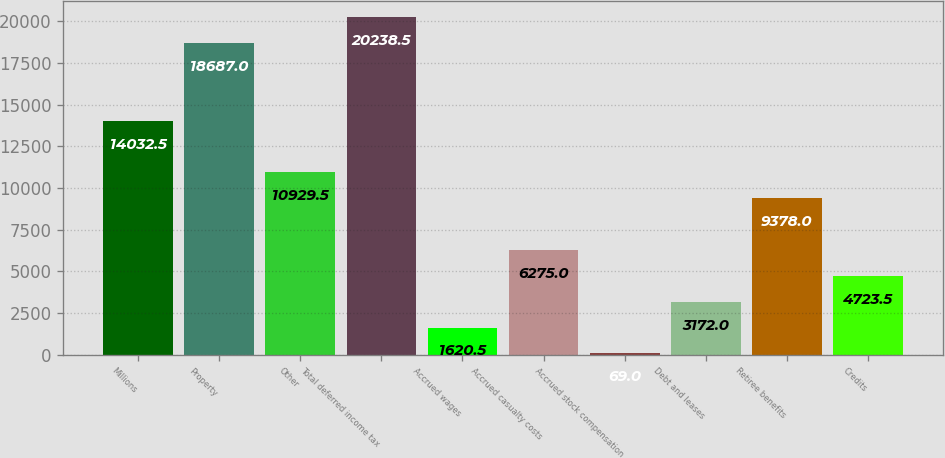Convert chart. <chart><loc_0><loc_0><loc_500><loc_500><bar_chart><fcel>Millions<fcel>Property<fcel>Other<fcel>Total deferred income tax<fcel>Accrued wages<fcel>Accrued casualty costs<fcel>Accrued stock compensation<fcel>Debt and leases<fcel>Retiree benefits<fcel>Credits<nl><fcel>14032.5<fcel>18687<fcel>10929.5<fcel>20238.5<fcel>1620.5<fcel>6275<fcel>69<fcel>3172<fcel>9378<fcel>4723.5<nl></chart> 